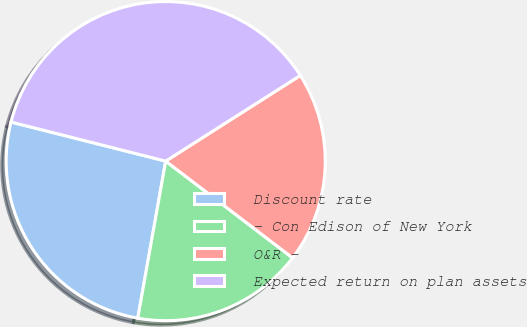<chart> <loc_0><loc_0><loc_500><loc_500><pie_chart><fcel>Discount rate<fcel>- Con Edison of New York<fcel>O&R -<fcel>Expected return on plan assets<nl><fcel>26.14%<fcel>17.43%<fcel>19.39%<fcel>37.04%<nl></chart> 